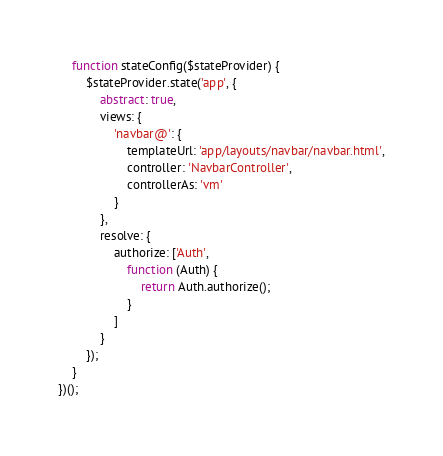Convert code to text. <code><loc_0><loc_0><loc_500><loc_500><_JavaScript_>    function stateConfig($stateProvider) {
        $stateProvider.state('app', {
            abstract: true,
            views: {
                'navbar@': {
                    templateUrl: 'app/layouts/navbar/navbar.html',
                    controller: 'NavbarController',
                    controllerAs: 'vm'
                }
            },
            resolve: {
                authorize: ['Auth',
                    function (Auth) {
                        return Auth.authorize();
                    }
                ]
            }
        });
    }
})();
</code> 